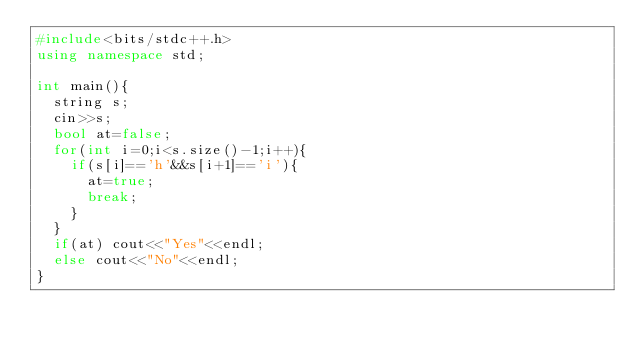<code> <loc_0><loc_0><loc_500><loc_500><_C++_>#include<bits/stdc++.h>
using namespace std;

int main(){
  string s;
  cin>>s;
  bool at=false;
  for(int i=0;i<s.size()-1;i++){
    if(s[i]=='h'&&s[i+1]=='i'){
      at=true;
      break;
    }
  }
  if(at) cout<<"Yes"<<endl;
  else cout<<"No"<<endl;
}

</code> 